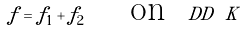<formula> <loc_0><loc_0><loc_500><loc_500>f = f _ { 1 } + f _ { 2 } \quad \text { on } \ D D \ K</formula> 